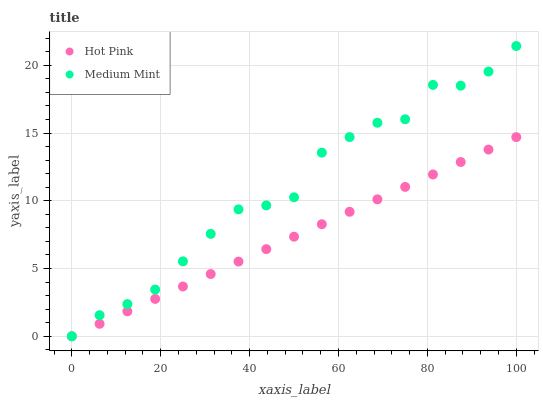Does Hot Pink have the minimum area under the curve?
Answer yes or no. Yes. Does Medium Mint have the maximum area under the curve?
Answer yes or no. Yes. Does Hot Pink have the maximum area under the curve?
Answer yes or no. No. Is Hot Pink the smoothest?
Answer yes or no. Yes. Is Medium Mint the roughest?
Answer yes or no. Yes. Is Hot Pink the roughest?
Answer yes or no. No. Does Medium Mint have the lowest value?
Answer yes or no. Yes. Does Medium Mint have the highest value?
Answer yes or no. Yes. Does Hot Pink have the highest value?
Answer yes or no. No. Does Hot Pink intersect Medium Mint?
Answer yes or no. Yes. Is Hot Pink less than Medium Mint?
Answer yes or no. No. Is Hot Pink greater than Medium Mint?
Answer yes or no. No. 